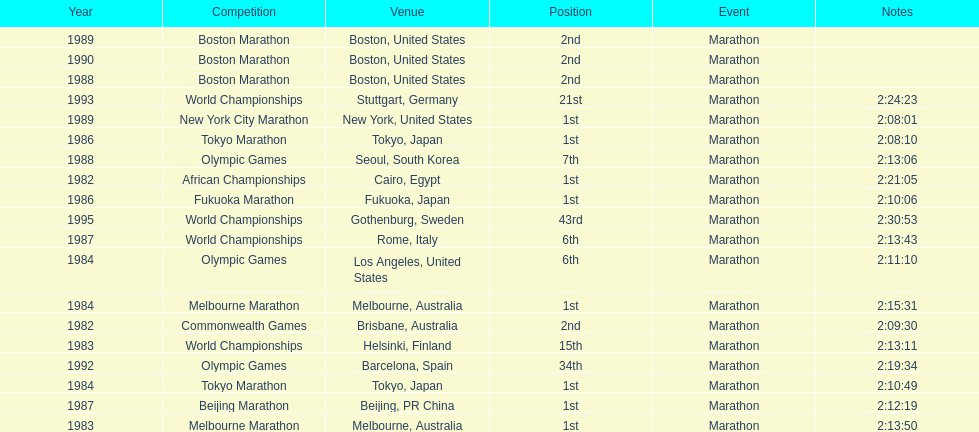What are the total number of times the position of 1st place was earned? 8. 